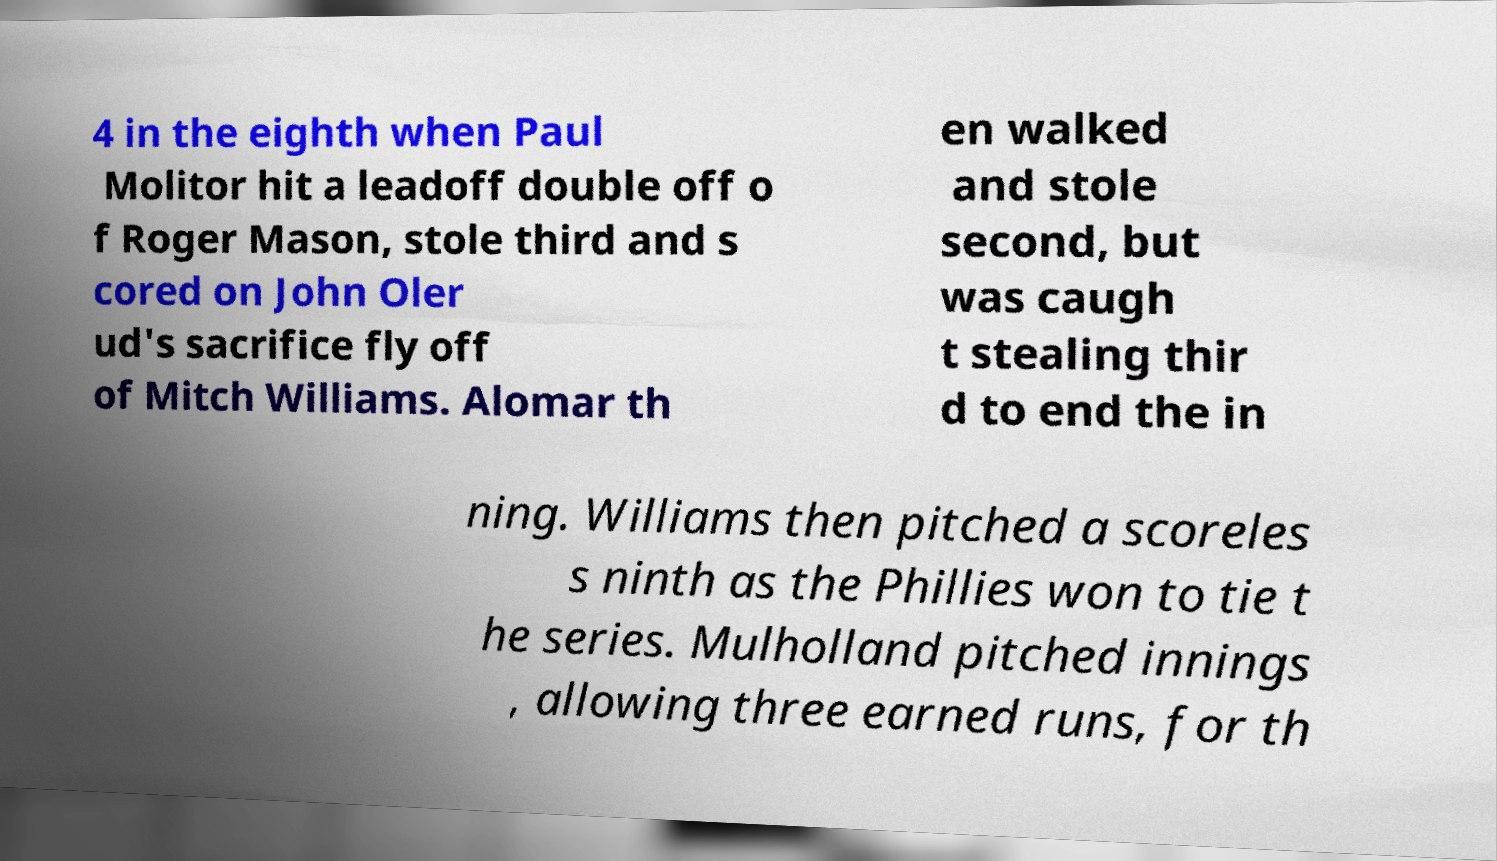I need the written content from this picture converted into text. Can you do that? 4 in the eighth when Paul Molitor hit a leadoff double off o f Roger Mason, stole third and s cored on John Oler ud's sacrifice fly off of Mitch Williams. Alomar th en walked and stole second, but was caugh t stealing thir d to end the in ning. Williams then pitched a scoreles s ninth as the Phillies won to tie t he series. Mulholland pitched innings , allowing three earned runs, for th 